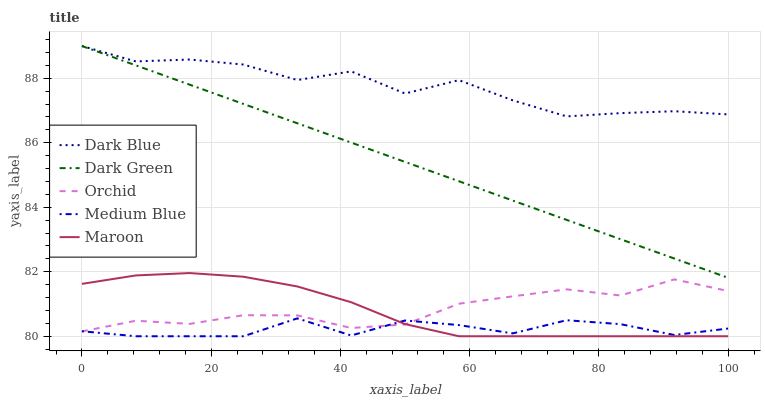Does Medium Blue have the minimum area under the curve?
Answer yes or no. Yes. Does Dark Blue have the maximum area under the curve?
Answer yes or no. Yes. Does Orchid have the minimum area under the curve?
Answer yes or no. No. Does Orchid have the maximum area under the curve?
Answer yes or no. No. Is Dark Green the smoothest?
Answer yes or no. Yes. Is Dark Blue the roughest?
Answer yes or no. Yes. Is Orchid the smoothest?
Answer yes or no. No. Is Orchid the roughest?
Answer yes or no. No. Does Medium Blue have the lowest value?
Answer yes or no. Yes. Does Orchid have the lowest value?
Answer yes or no. No. Does Dark Green have the highest value?
Answer yes or no. Yes. Does Orchid have the highest value?
Answer yes or no. No. Is Orchid less than Dark Blue?
Answer yes or no. Yes. Is Dark Blue greater than Orchid?
Answer yes or no. Yes. Does Medium Blue intersect Orchid?
Answer yes or no. Yes. Is Medium Blue less than Orchid?
Answer yes or no. No. Is Medium Blue greater than Orchid?
Answer yes or no. No. Does Orchid intersect Dark Blue?
Answer yes or no. No. 